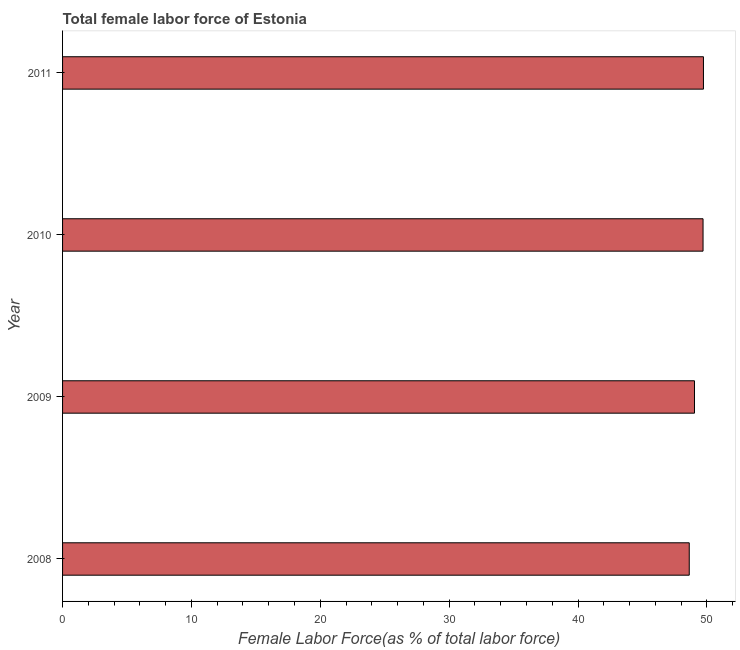What is the title of the graph?
Your answer should be very brief. Total female labor force of Estonia. What is the label or title of the X-axis?
Offer a terse response. Female Labor Force(as % of total labor force). What is the total female labor force in 2010?
Ensure brevity in your answer.  49.7. Across all years, what is the maximum total female labor force?
Your answer should be very brief. 49.73. Across all years, what is the minimum total female labor force?
Give a very brief answer. 48.63. What is the sum of the total female labor force?
Provide a short and direct response. 197.09. What is the difference between the total female labor force in 2009 and 2010?
Provide a succinct answer. -0.66. What is the average total female labor force per year?
Provide a short and direct response. 49.27. What is the median total female labor force?
Provide a short and direct response. 49.37. What is the ratio of the total female labor force in 2008 to that in 2011?
Offer a very short reply. 0.98. Is the total female labor force in 2008 less than that in 2009?
Give a very brief answer. Yes. Is the difference between the total female labor force in 2009 and 2011 greater than the difference between any two years?
Offer a terse response. No. What is the difference between the highest and the second highest total female labor force?
Your answer should be compact. 0.03. Is the sum of the total female labor force in 2008 and 2011 greater than the maximum total female labor force across all years?
Your response must be concise. Yes. What is the difference between the highest and the lowest total female labor force?
Provide a short and direct response. 1.1. How many bars are there?
Keep it short and to the point. 4. How many years are there in the graph?
Keep it short and to the point. 4. What is the difference between two consecutive major ticks on the X-axis?
Your answer should be very brief. 10. Are the values on the major ticks of X-axis written in scientific E-notation?
Your answer should be very brief. No. What is the Female Labor Force(as % of total labor force) in 2008?
Your response must be concise. 48.63. What is the Female Labor Force(as % of total labor force) of 2009?
Provide a succinct answer. 49.03. What is the Female Labor Force(as % of total labor force) of 2010?
Give a very brief answer. 49.7. What is the Female Labor Force(as % of total labor force) in 2011?
Give a very brief answer. 49.73. What is the difference between the Female Labor Force(as % of total labor force) in 2008 and 2009?
Offer a very short reply. -0.41. What is the difference between the Female Labor Force(as % of total labor force) in 2008 and 2010?
Offer a terse response. -1.07. What is the difference between the Female Labor Force(as % of total labor force) in 2008 and 2011?
Provide a short and direct response. -1.1. What is the difference between the Female Labor Force(as % of total labor force) in 2009 and 2010?
Your answer should be compact. -0.66. What is the difference between the Female Labor Force(as % of total labor force) in 2009 and 2011?
Your answer should be compact. -0.69. What is the difference between the Female Labor Force(as % of total labor force) in 2010 and 2011?
Provide a succinct answer. -0.03. What is the ratio of the Female Labor Force(as % of total labor force) in 2008 to that in 2009?
Make the answer very short. 0.99. What is the ratio of the Female Labor Force(as % of total labor force) in 2009 to that in 2010?
Your answer should be very brief. 0.99. 